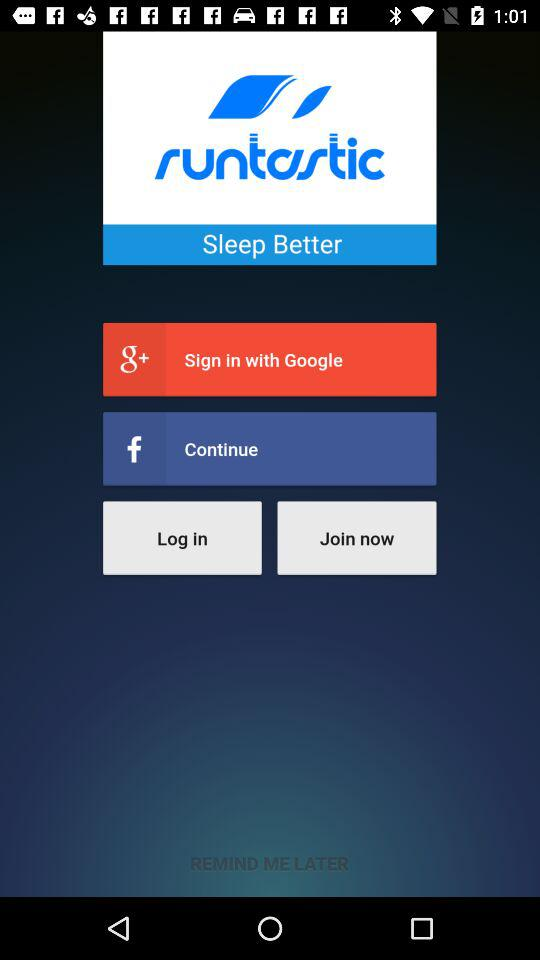What other application can we use for login rather than Google? The application is "Facebook". 